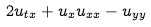Convert formula to latex. <formula><loc_0><loc_0><loc_500><loc_500>2 u _ { t x } + u _ { x } u _ { x x } - u _ { y y }</formula> 